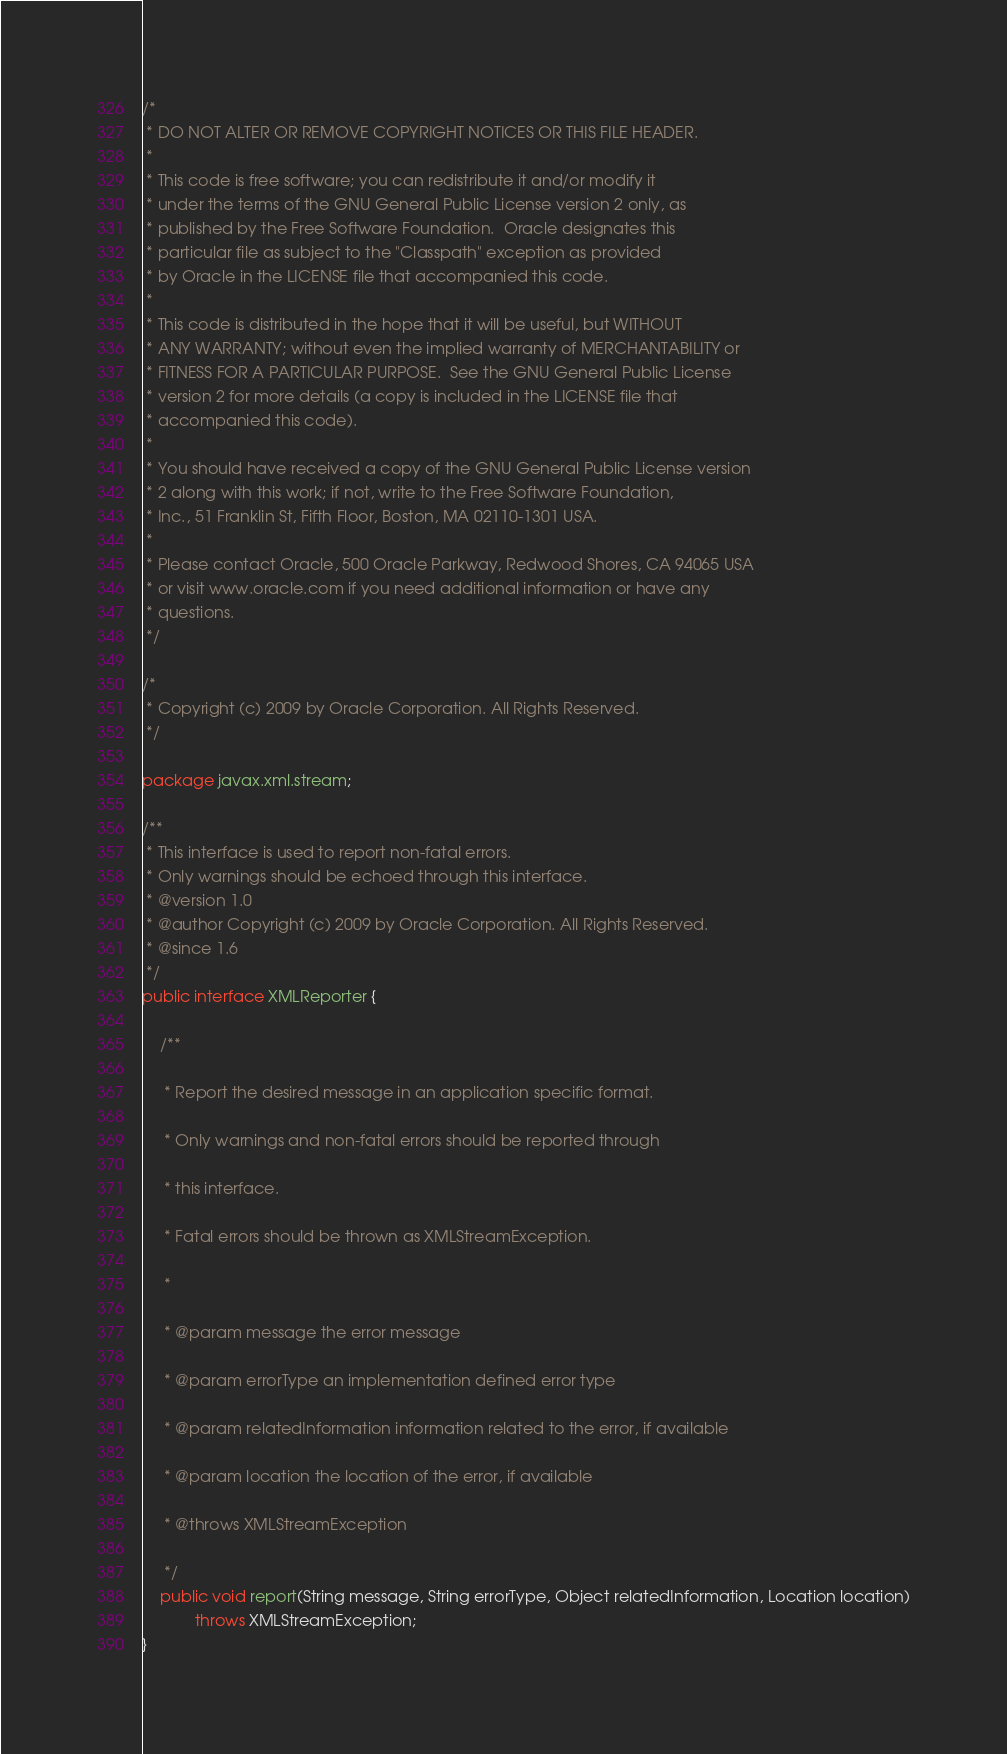<code> <loc_0><loc_0><loc_500><loc_500><_Java_>/*
 * DO NOT ALTER OR REMOVE COPYRIGHT NOTICES OR THIS FILE HEADER.
 *
 * This code is free software; you can redistribute it and/or modify it
 * under the terms of the GNU General Public License version 2 only, as
 * published by the Free Software Foundation.  Oracle designates this
 * particular file as subject to the "Classpath" exception as provided
 * by Oracle in the LICENSE file that accompanied this code.
 *
 * This code is distributed in the hope that it will be useful, but WITHOUT
 * ANY WARRANTY; without even the implied warranty of MERCHANTABILITY or
 * FITNESS FOR A PARTICULAR PURPOSE.  See the GNU General Public License
 * version 2 for more details (a copy is included in the LICENSE file that
 * accompanied this code).
 *
 * You should have received a copy of the GNU General Public License version
 * 2 along with this work; if not, write to the Free Software Foundation,
 * Inc., 51 Franklin St, Fifth Floor, Boston, MA 02110-1301 USA.
 *
 * Please contact Oracle, 500 Oracle Parkway, Redwood Shores, CA 94065 USA
 * or visit www.oracle.com if you need additional information or have any
 * questions.
 */

/*
 * Copyright (c) 2009 by Oracle Corporation. All Rights Reserved.
 */

package javax.xml.stream;

/**
 * This interface is used to report non-fatal errors.
 * Only warnings should be echoed through this interface.
 * @version 1.0
 * @author Copyright (c) 2009 by Oracle Corporation. All Rights Reserved.
 * @since 1.6
 */
public interface XMLReporter {

    /**

     * Report the desired message in an application specific format.

     * Only warnings and non-fatal errors should be reported through

     * this interface.

     * Fatal errors should be thrown as XMLStreamException.

     *

     * @param message the error message

     * @param errorType an implementation defined error type

     * @param relatedInformation information related to the error, if available

     * @param location the location of the error, if available

     * @throws XMLStreamException

     */
    public void report(String message, String errorType, Object relatedInformation, Location location)
            throws XMLStreamException;
}
</code> 